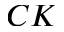Convert formula to latex. <formula><loc_0><loc_0><loc_500><loc_500>C K</formula> 